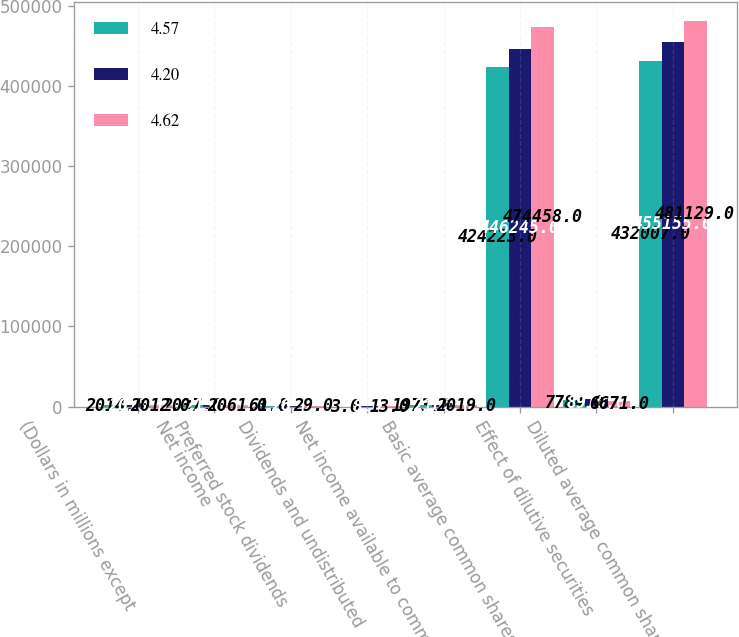Convert chart to OTSL. <chart><loc_0><loc_0><loc_500><loc_500><stacked_bar_chart><ecel><fcel>(Dollars in millions except<fcel>Net income<fcel>Preferred stock dividends<fcel>Dividends and undistributed<fcel>Net income available to common<fcel>Basic average common shares<fcel>Effect of dilutive securities<fcel>Diluted average common shares<nl><fcel>4.57<fcel>2014<fcel>2037<fcel>61<fcel>3<fcel>1973<fcel>424223<fcel>7784<fcel>432007<nl><fcel>4.2<fcel>2013<fcel>2136<fcel>26<fcel>8<fcel>2102<fcel>446245<fcel>8910<fcel>455155<nl><fcel>4.62<fcel>2012<fcel>2061<fcel>29<fcel>13<fcel>2019<fcel>474458<fcel>6671<fcel>481129<nl></chart> 